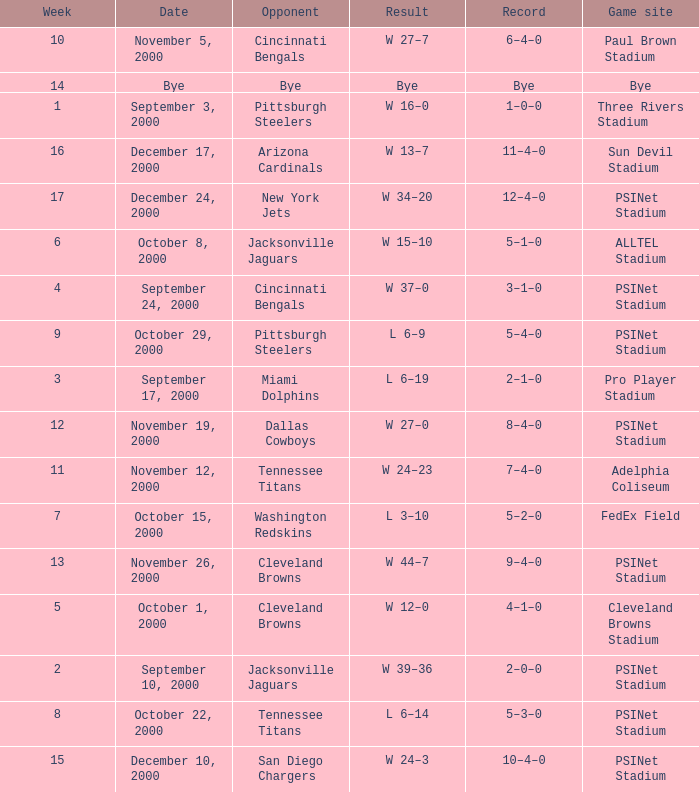What's the record after week 16? 12–4–0. 